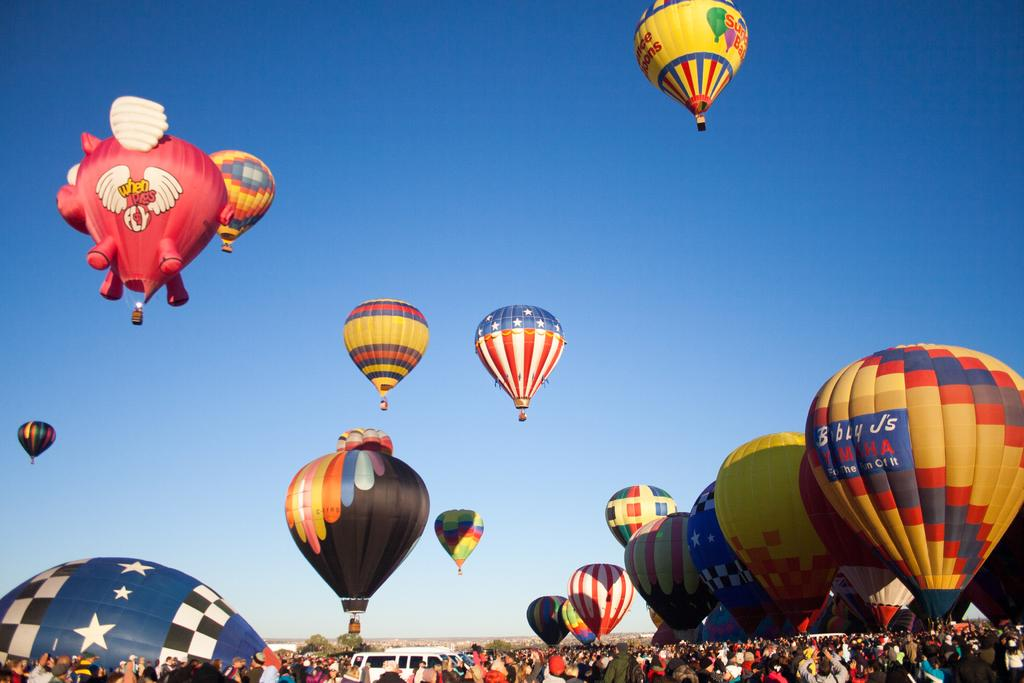Provide a one-sentence caption for the provided image. A variety of hot air balloons and one sponsored by Bobby J's Yamaha. 